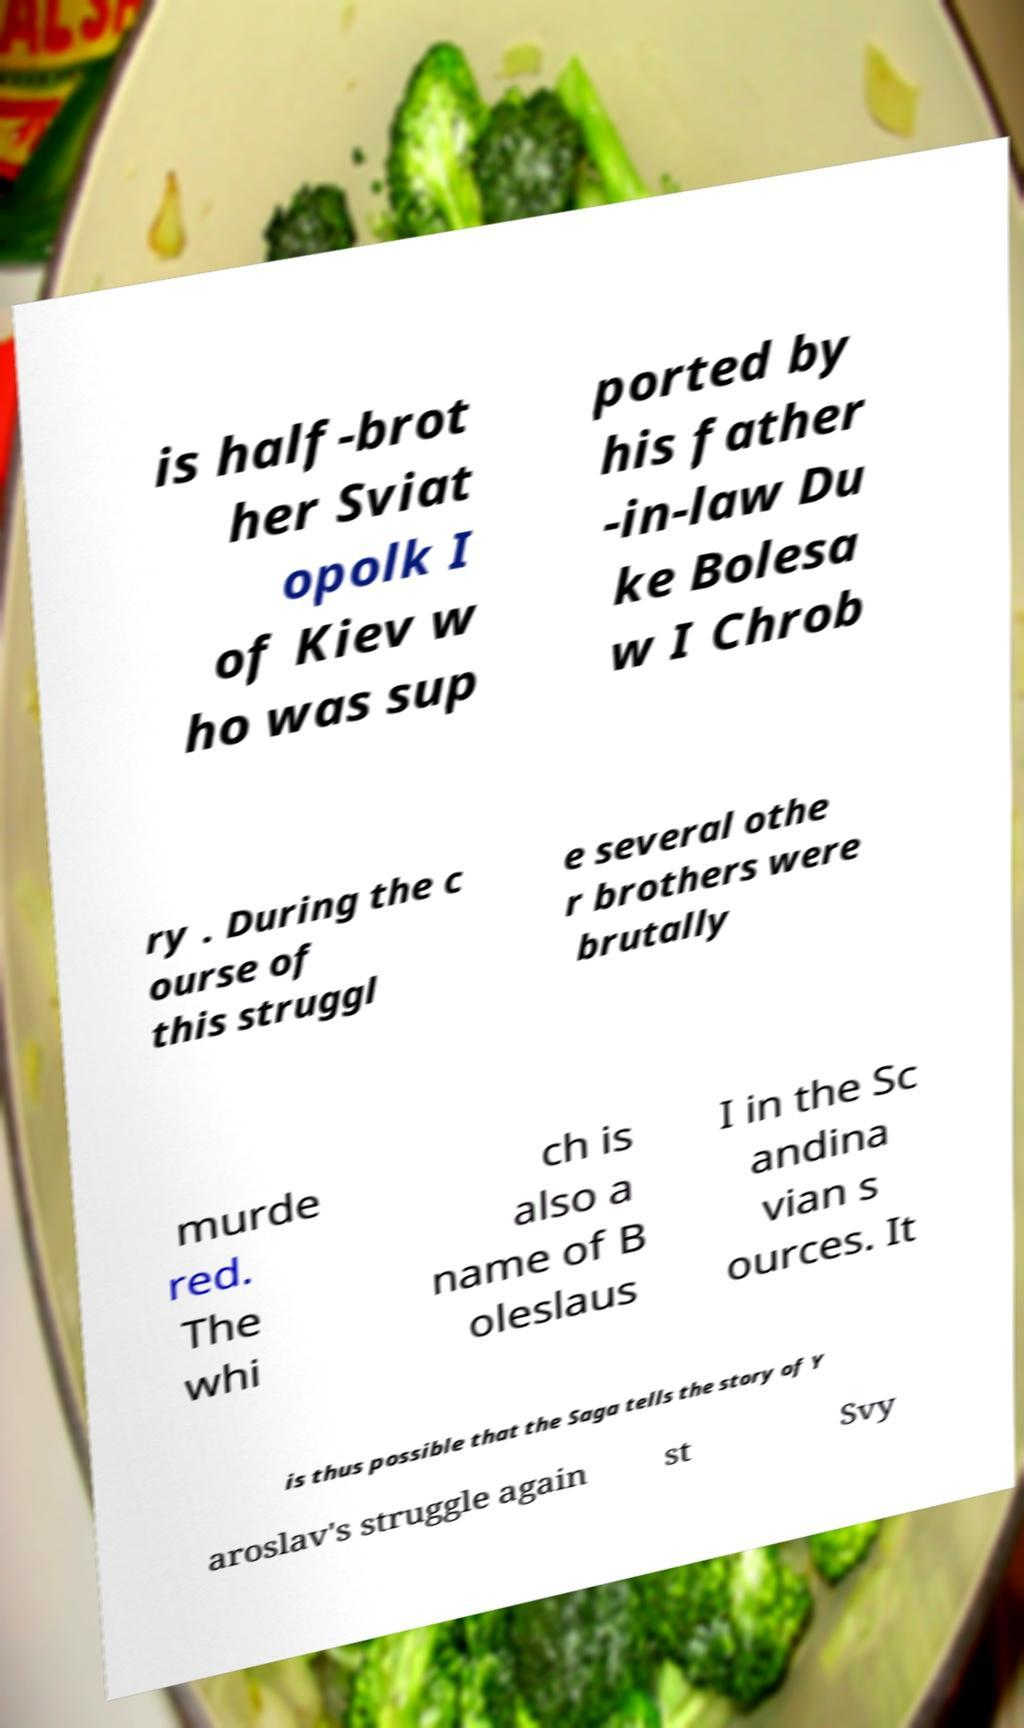Please read and relay the text visible in this image. What does it say? is half-brot her Sviat opolk I of Kiev w ho was sup ported by his father -in-law Du ke Bolesa w I Chrob ry . During the c ourse of this struggl e several othe r brothers were brutally murde red. The whi ch is also a name of B oleslaus I in the Sc andina vian s ources. It is thus possible that the Saga tells the story of Y aroslav's struggle again st Svy 